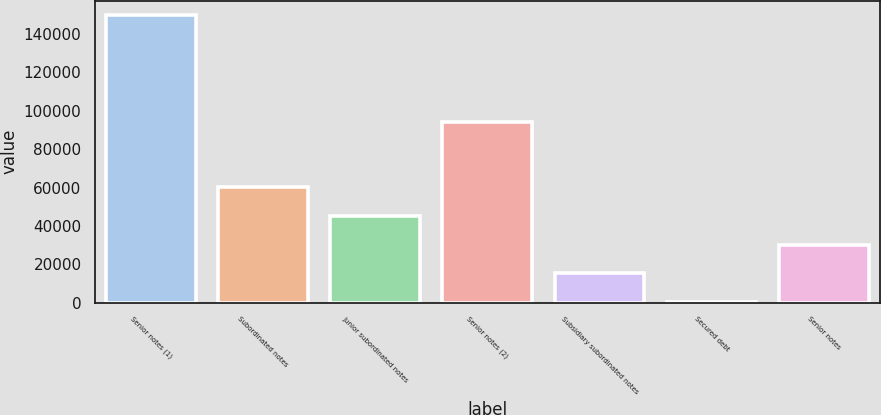Convert chart to OTSL. <chart><loc_0><loc_0><loc_500><loc_500><bar_chart><fcel>Senior notes (1)<fcel>Subordinated notes<fcel>Junior subordinated notes<fcel>Senior notes (2)<fcel>Subsidiary subordinated notes<fcel>Secured debt<fcel>Senior notes<nl><fcel>149751<fcel>60095.4<fcel>45152.8<fcel>93909<fcel>15267.6<fcel>325<fcel>30210.2<nl></chart> 